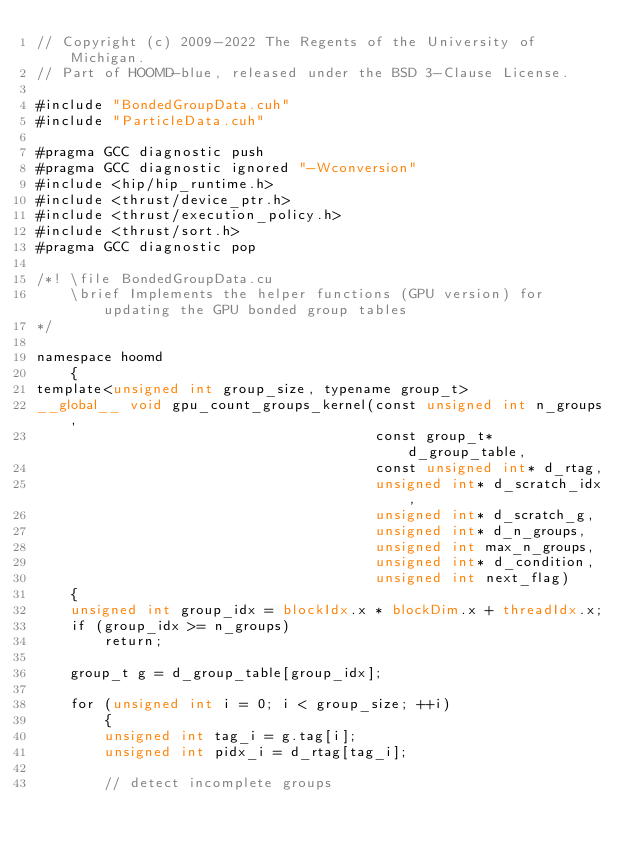<code> <loc_0><loc_0><loc_500><loc_500><_Cuda_>// Copyright (c) 2009-2022 The Regents of the University of Michigan.
// Part of HOOMD-blue, released under the BSD 3-Clause License.

#include "BondedGroupData.cuh"
#include "ParticleData.cuh"

#pragma GCC diagnostic push
#pragma GCC diagnostic ignored "-Wconversion"
#include <hip/hip_runtime.h>
#include <thrust/device_ptr.h>
#include <thrust/execution_policy.h>
#include <thrust/sort.h>
#pragma GCC diagnostic pop

/*! \file BondedGroupData.cu
    \brief Implements the helper functions (GPU version) for updating the GPU bonded group tables
*/

namespace hoomd
    {
template<unsigned int group_size, typename group_t>
__global__ void gpu_count_groups_kernel(const unsigned int n_groups,
                                        const group_t* d_group_table,
                                        const unsigned int* d_rtag,
                                        unsigned int* d_scratch_idx,
                                        unsigned int* d_scratch_g,
                                        unsigned int* d_n_groups,
                                        unsigned int max_n_groups,
                                        unsigned int* d_condition,
                                        unsigned int next_flag)
    {
    unsigned int group_idx = blockIdx.x * blockDim.x + threadIdx.x;
    if (group_idx >= n_groups)
        return;

    group_t g = d_group_table[group_idx];

    for (unsigned int i = 0; i < group_size; ++i)
        {
        unsigned int tag_i = g.tag[i];
        unsigned int pidx_i = d_rtag[tag_i];

        // detect incomplete groups</code> 